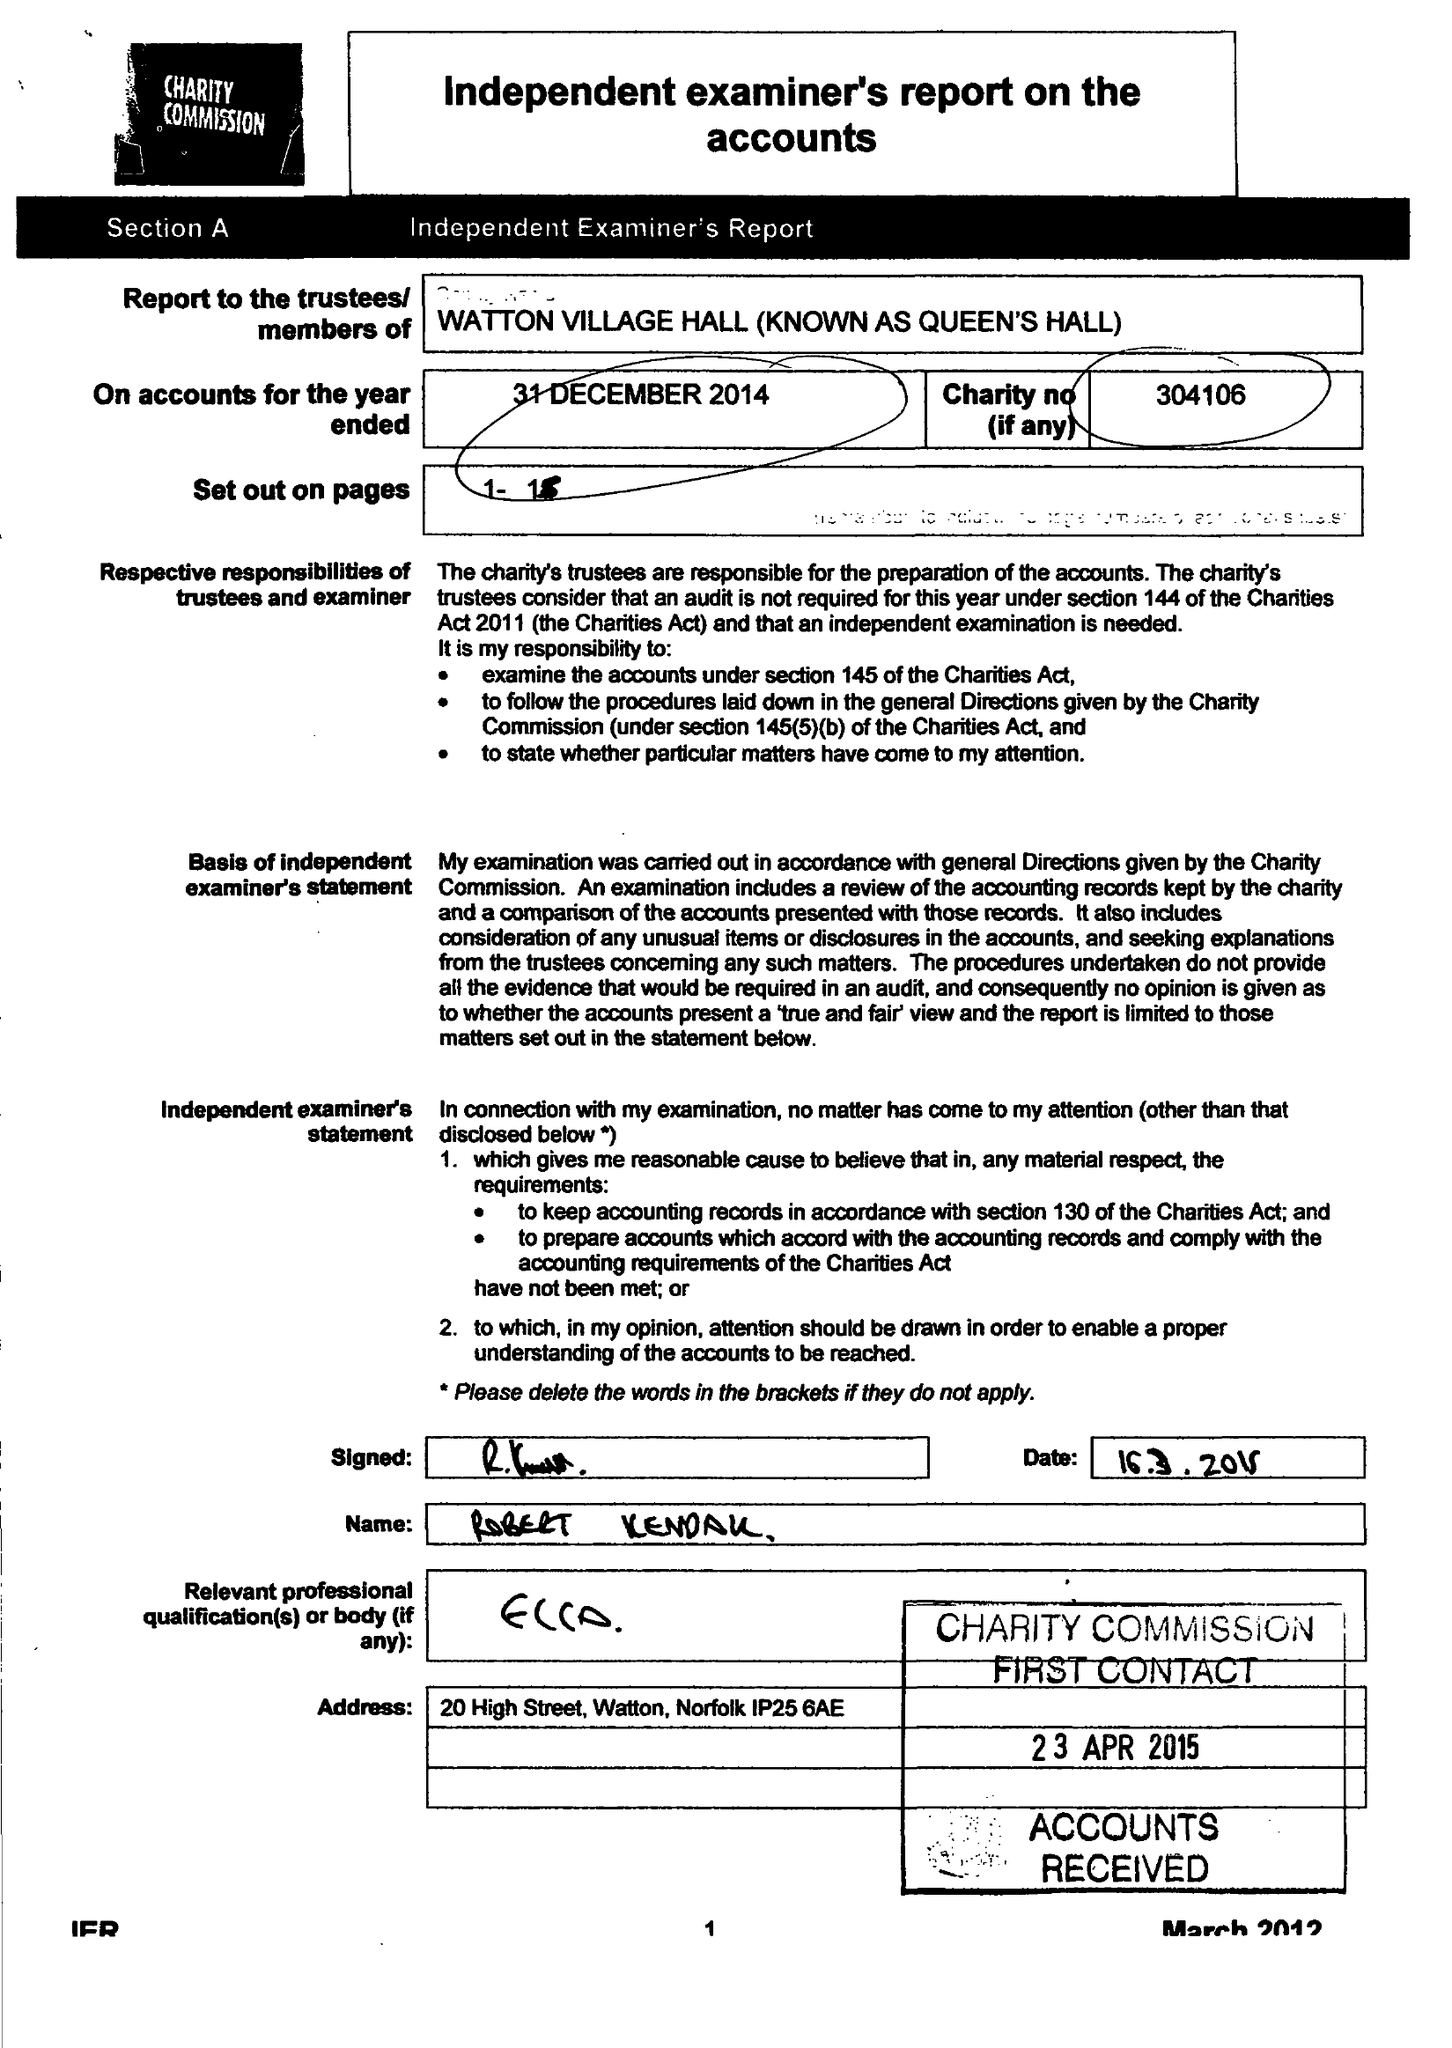What is the value for the report_date?
Answer the question using a single word or phrase. 2014-12-31 